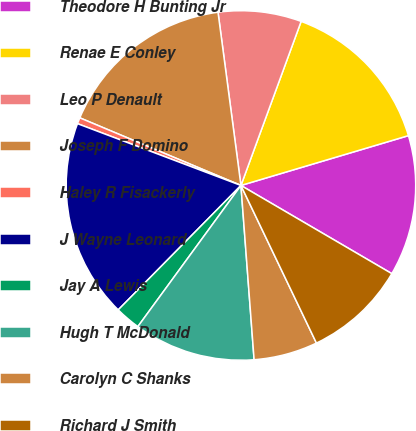<chart> <loc_0><loc_0><loc_500><loc_500><pie_chart><fcel>Theodore H Bunting Jr<fcel>Renae E Conley<fcel>Leo P Denault<fcel>Joseph F Domino<fcel>Haley R Fisackerly<fcel>J Wayne Leonard<fcel>Jay A Lewis<fcel>Hugh T McDonald<fcel>Carolyn C Shanks<fcel>Richard J Smith<nl><fcel>13.02%<fcel>14.8%<fcel>7.69%<fcel>16.58%<fcel>0.57%<fcel>18.36%<fcel>2.35%<fcel>11.24%<fcel>5.91%<fcel>9.47%<nl></chart> 